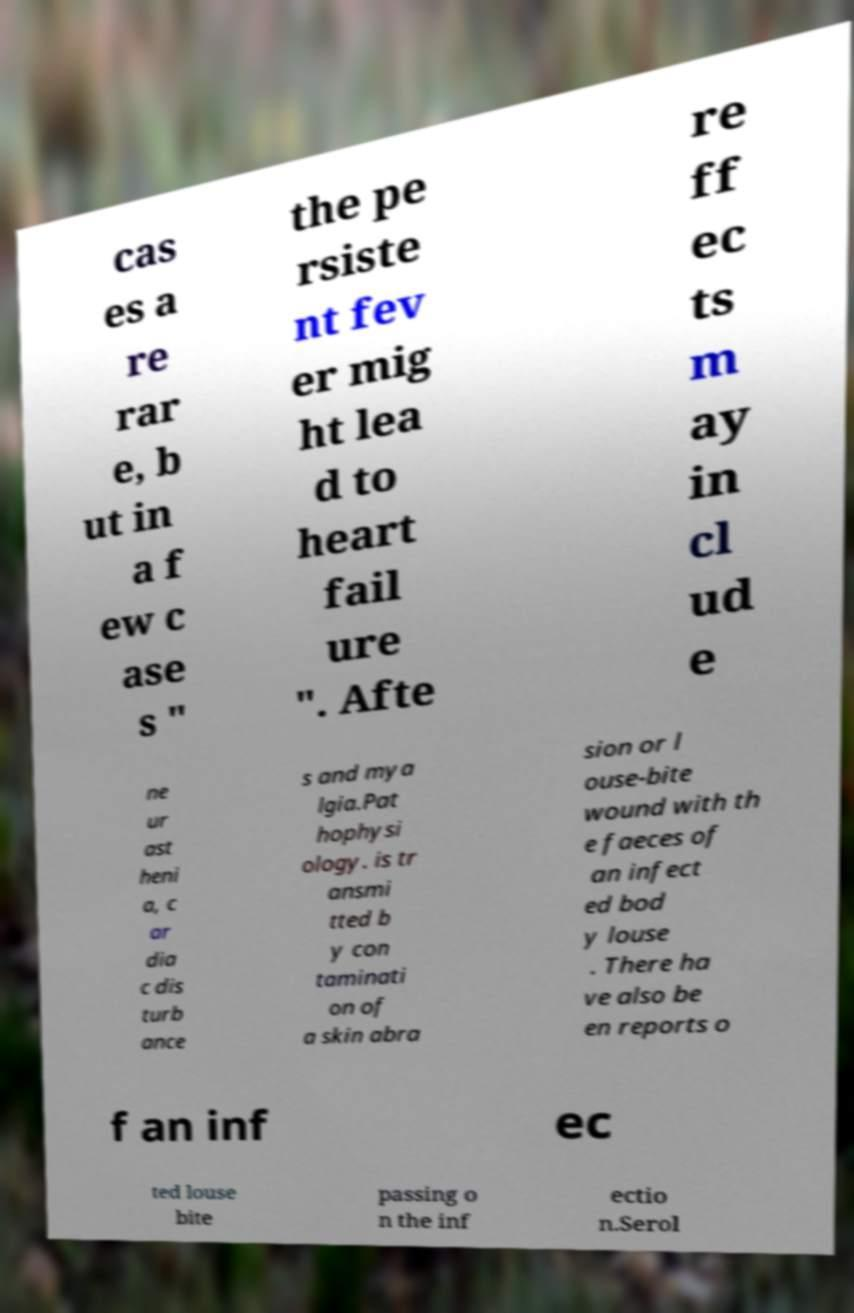Please identify and transcribe the text found in this image. cas es a re rar e, b ut in a f ew c ase s " the pe rsiste nt fev er mig ht lea d to heart fail ure ". Afte re ff ec ts m ay in cl ud e ne ur ast heni a, c ar dia c dis turb ance s and mya lgia.Pat hophysi ology. is tr ansmi tted b y con taminati on of a skin abra sion or l ouse-bite wound with th e faeces of an infect ed bod y louse . There ha ve also be en reports o f an inf ec ted louse bite passing o n the inf ectio n.Serol 